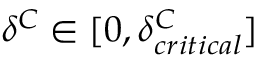Convert formula to latex. <formula><loc_0><loc_0><loc_500><loc_500>\delta ^ { C } \in [ 0 , \delta _ { c r i t i c a l } ^ { C } ]</formula> 